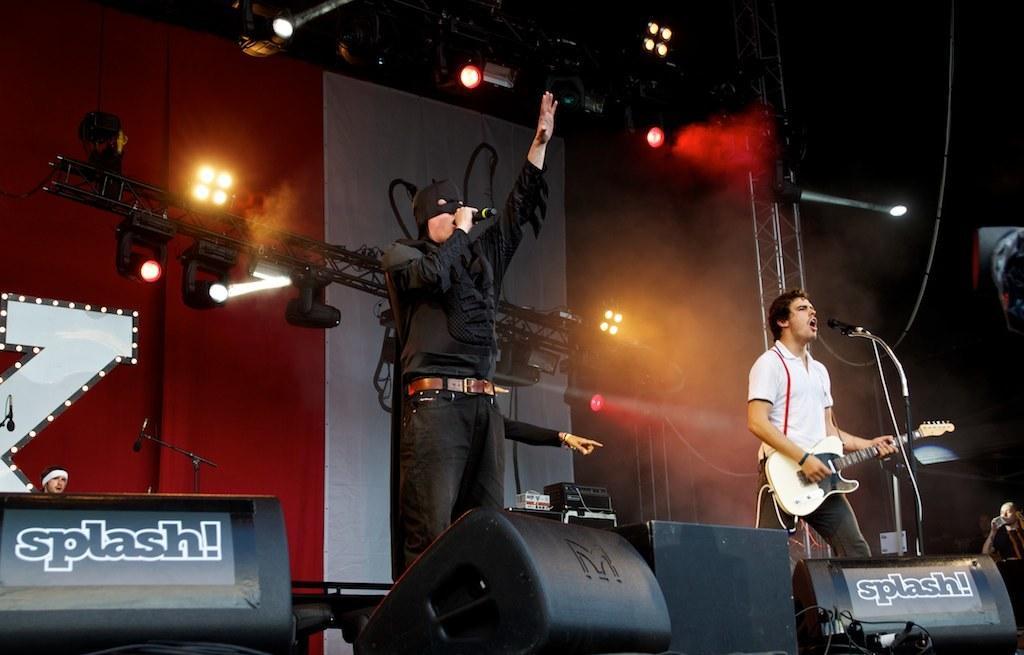In one or two sentences, can you explain what this image depicts? The person wearing bat man dress is singing in front of a mic and there is another person playing guitar and singing in front of a mic. 